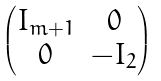Convert formula to latex. <formula><loc_0><loc_0><loc_500><loc_500>\begin{pmatrix} I _ { m + 1 } & 0 \\ 0 & - I _ { 2 } \end{pmatrix}</formula> 